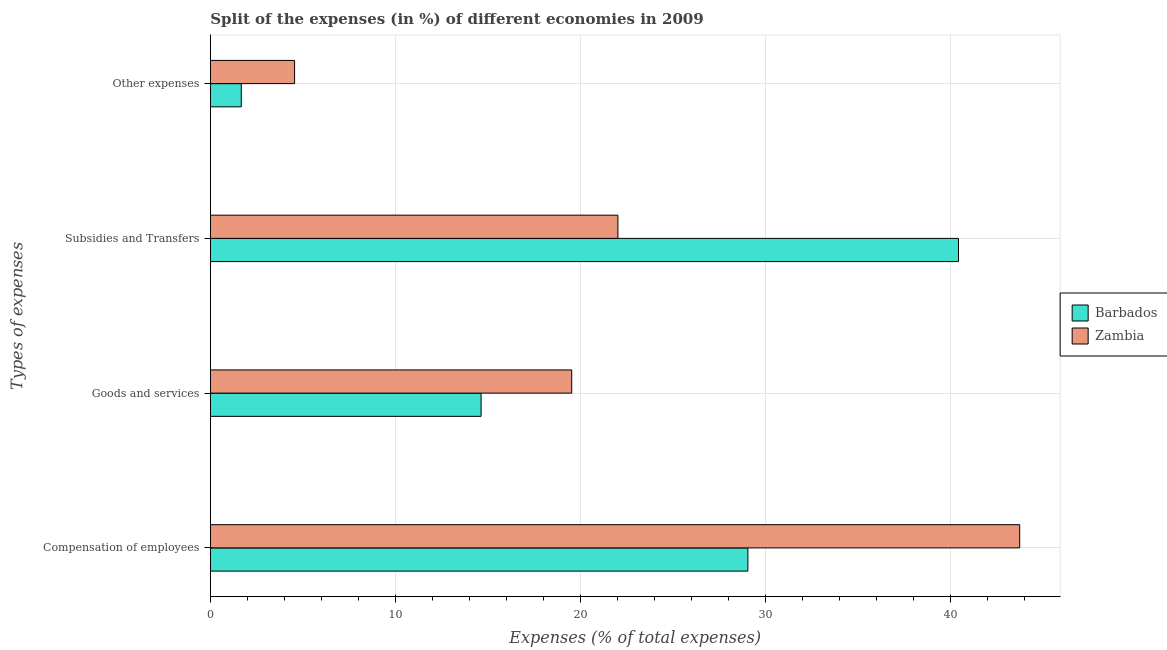How many groups of bars are there?
Ensure brevity in your answer.  4. Are the number of bars per tick equal to the number of legend labels?
Keep it short and to the point. Yes. Are the number of bars on each tick of the Y-axis equal?
Offer a terse response. Yes. How many bars are there on the 2nd tick from the bottom?
Keep it short and to the point. 2. What is the label of the 3rd group of bars from the top?
Provide a succinct answer. Goods and services. What is the percentage of amount spent on goods and services in Barbados?
Offer a terse response. 14.64. Across all countries, what is the maximum percentage of amount spent on goods and services?
Ensure brevity in your answer.  19.54. Across all countries, what is the minimum percentage of amount spent on goods and services?
Provide a succinct answer. 14.64. In which country was the percentage of amount spent on goods and services maximum?
Give a very brief answer. Zambia. In which country was the percentage of amount spent on compensation of employees minimum?
Your answer should be very brief. Barbados. What is the total percentage of amount spent on subsidies in the graph?
Give a very brief answer. 62.49. What is the difference between the percentage of amount spent on subsidies in Barbados and that in Zambia?
Offer a very short reply. 18.42. What is the difference between the percentage of amount spent on goods and services in Barbados and the percentage of amount spent on compensation of employees in Zambia?
Make the answer very short. -29.12. What is the average percentage of amount spent on other expenses per country?
Offer a terse response. 3.11. What is the difference between the percentage of amount spent on subsidies and percentage of amount spent on compensation of employees in Barbados?
Offer a very short reply. 11.39. In how many countries, is the percentage of amount spent on compensation of employees greater than 36 %?
Offer a terse response. 1. What is the ratio of the percentage of amount spent on goods and services in Zambia to that in Barbados?
Provide a succinct answer. 1.33. What is the difference between the highest and the second highest percentage of amount spent on goods and services?
Offer a terse response. 4.9. What is the difference between the highest and the lowest percentage of amount spent on compensation of employees?
Keep it short and to the point. 14.7. In how many countries, is the percentage of amount spent on compensation of employees greater than the average percentage of amount spent on compensation of employees taken over all countries?
Ensure brevity in your answer.  1. Is the sum of the percentage of amount spent on subsidies in Zambia and Barbados greater than the maximum percentage of amount spent on goods and services across all countries?
Provide a short and direct response. Yes. What does the 1st bar from the top in Other expenses represents?
Offer a very short reply. Zambia. What does the 1st bar from the bottom in Compensation of employees represents?
Ensure brevity in your answer.  Barbados. Is it the case that in every country, the sum of the percentage of amount spent on compensation of employees and percentage of amount spent on goods and services is greater than the percentage of amount spent on subsidies?
Offer a terse response. Yes. Are all the bars in the graph horizontal?
Your answer should be very brief. Yes. Where does the legend appear in the graph?
Your answer should be compact. Center right. How many legend labels are there?
Your response must be concise. 2. What is the title of the graph?
Offer a terse response. Split of the expenses (in %) of different economies in 2009. What is the label or title of the X-axis?
Your answer should be compact. Expenses (% of total expenses). What is the label or title of the Y-axis?
Provide a succinct answer. Types of expenses. What is the Expenses (% of total expenses) of Barbados in Compensation of employees?
Give a very brief answer. 29.06. What is the Expenses (% of total expenses) of Zambia in Compensation of employees?
Offer a very short reply. 43.76. What is the Expenses (% of total expenses) in Barbados in Goods and services?
Make the answer very short. 14.64. What is the Expenses (% of total expenses) of Zambia in Goods and services?
Offer a very short reply. 19.54. What is the Expenses (% of total expenses) in Barbados in Subsidies and Transfers?
Your response must be concise. 40.45. What is the Expenses (% of total expenses) in Zambia in Subsidies and Transfers?
Your response must be concise. 22.04. What is the Expenses (% of total expenses) in Barbados in Other expenses?
Your answer should be very brief. 1.67. What is the Expenses (% of total expenses) in Zambia in Other expenses?
Make the answer very short. 4.55. Across all Types of expenses, what is the maximum Expenses (% of total expenses) in Barbados?
Your response must be concise. 40.45. Across all Types of expenses, what is the maximum Expenses (% of total expenses) in Zambia?
Give a very brief answer. 43.76. Across all Types of expenses, what is the minimum Expenses (% of total expenses) in Barbados?
Make the answer very short. 1.67. Across all Types of expenses, what is the minimum Expenses (% of total expenses) in Zambia?
Make the answer very short. 4.55. What is the total Expenses (% of total expenses) in Barbados in the graph?
Make the answer very short. 85.82. What is the total Expenses (% of total expenses) of Zambia in the graph?
Keep it short and to the point. 89.89. What is the difference between the Expenses (% of total expenses) of Barbados in Compensation of employees and that in Goods and services?
Offer a very short reply. 14.43. What is the difference between the Expenses (% of total expenses) in Zambia in Compensation of employees and that in Goods and services?
Provide a succinct answer. 24.22. What is the difference between the Expenses (% of total expenses) in Barbados in Compensation of employees and that in Subsidies and Transfers?
Make the answer very short. -11.39. What is the difference between the Expenses (% of total expenses) of Zambia in Compensation of employees and that in Subsidies and Transfers?
Offer a terse response. 21.73. What is the difference between the Expenses (% of total expenses) of Barbados in Compensation of employees and that in Other expenses?
Offer a very short reply. 27.39. What is the difference between the Expenses (% of total expenses) of Zambia in Compensation of employees and that in Other expenses?
Your answer should be very brief. 39.21. What is the difference between the Expenses (% of total expenses) of Barbados in Goods and services and that in Subsidies and Transfers?
Your answer should be compact. -25.81. What is the difference between the Expenses (% of total expenses) of Zambia in Goods and services and that in Subsidies and Transfers?
Offer a very short reply. -2.5. What is the difference between the Expenses (% of total expenses) in Barbados in Goods and services and that in Other expenses?
Provide a succinct answer. 12.97. What is the difference between the Expenses (% of total expenses) of Zambia in Goods and services and that in Other expenses?
Your answer should be very brief. 14.98. What is the difference between the Expenses (% of total expenses) in Barbados in Subsidies and Transfers and that in Other expenses?
Ensure brevity in your answer.  38.78. What is the difference between the Expenses (% of total expenses) of Zambia in Subsidies and Transfers and that in Other expenses?
Give a very brief answer. 17.48. What is the difference between the Expenses (% of total expenses) of Barbados in Compensation of employees and the Expenses (% of total expenses) of Zambia in Goods and services?
Provide a succinct answer. 9.53. What is the difference between the Expenses (% of total expenses) of Barbados in Compensation of employees and the Expenses (% of total expenses) of Zambia in Subsidies and Transfers?
Offer a very short reply. 7.03. What is the difference between the Expenses (% of total expenses) in Barbados in Compensation of employees and the Expenses (% of total expenses) in Zambia in Other expenses?
Give a very brief answer. 24.51. What is the difference between the Expenses (% of total expenses) of Barbados in Goods and services and the Expenses (% of total expenses) of Zambia in Subsidies and Transfers?
Give a very brief answer. -7.4. What is the difference between the Expenses (% of total expenses) in Barbados in Goods and services and the Expenses (% of total expenses) in Zambia in Other expenses?
Offer a very short reply. 10.09. What is the difference between the Expenses (% of total expenses) of Barbados in Subsidies and Transfers and the Expenses (% of total expenses) of Zambia in Other expenses?
Ensure brevity in your answer.  35.9. What is the average Expenses (% of total expenses) of Barbados per Types of expenses?
Offer a terse response. 21.46. What is the average Expenses (% of total expenses) of Zambia per Types of expenses?
Make the answer very short. 22.47. What is the difference between the Expenses (% of total expenses) of Barbados and Expenses (% of total expenses) of Zambia in Compensation of employees?
Provide a short and direct response. -14.7. What is the difference between the Expenses (% of total expenses) of Barbados and Expenses (% of total expenses) of Zambia in Goods and services?
Keep it short and to the point. -4.9. What is the difference between the Expenses (% of total expenses) of Barbados and Expenses (% of total expenses) of Zambia in Subsidies and Transfers?
Keep it short and to the point. 18.42. What is the difference between the Expenses (% of total expenses) in Barbados and Expenses (% of total expenses) in Zambia in Other expenses?
Offer a terse response. -2.88. What is the ratio of the Expenses (% of total expenses) of Barbados in Compensation of employees to that in Goods and services?
Ensure brevity in your answer.  1.99. What is the ratio of the Expenses (% of total expenses) in Zambia in Compensation of employees to that in Goods and services?
Give a very brief answer. 2.24. What is the ratio of the Expenses (% of total expenses) of Barbados in Compensation of employees to that in Subsidies and Transfers?
Keep it short and to the point. 0.72. What is the ratio of the Expenses (% of total expenses) in Zambia in Compensation of employees to that in Subsidies and Transfers?
Give a very brief answer. 1.99. What is the ratio of the Expenses (% of total expenses) of Barbados in Compensation of employees to that in Other expenses?
Provide a short and direct response. 17.39. What is the ratio of the Expenses (% of total expenses) of Zambia in Compensation of employees to that in Other expenses?
Your answer should be very brief. 9.61. What is the ratio of the Expenses (% of total expenses) of Barbados in Goods and services to that in Subsidies and Transfers?
Your answer should be compact. 0.36. What is the ratio of the Expenses (% of total expenses) in Zambia in Goods and services to that in Subsidies and Transfers?
Make the answer very short. 0.89. What is the ratio of the Expenses (% of total expenses) of Barbados in Goods and services to that in Other expenses?
Offer a very short reply. 8.76. What is the ratio of the Expenses (% of total expenses) in Zambia in Goods and services to that in Other expenses?
Your answer should be compact. 4.29. What is the ratio of the Expenses (% of total expenses) in Barbados in Subsidies and Transfers to that in Other expenses?
Give a very brief answer. 24.21. What is the ratio of the Expenses (% of total expenses) of Zambia in Subsidies and Transfers to that in Other expenses?
Your answer should be compact. 4.84. What is the difference between the highest and the second highest Expenses (% of total expenses) in Barbados?
Ensure brevity in your answer.  11.39. What is the difference between the highest and the second highest Expenses (% of total expenses) in Zambia?
Ensure brevity in your answer.  21.73. What is the difference between the highest and the lowest Expenses (% of total expenses) in Barbados?
Your answer should be compact. 38.78. What is the difference between the highest and the lowest Expenses (% of total expenses) in Zambia?
Offer a very short reply. 39.21. 